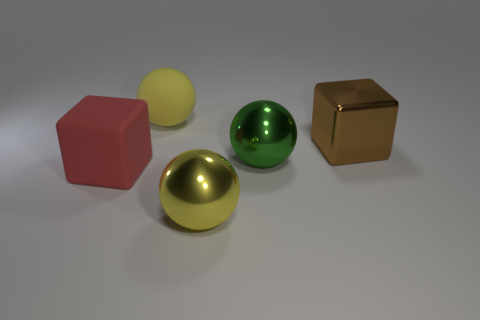Add 5 red cubes. How many objects exist? 10 Subtract all blocks. How many objects are left? 3 Add 5 large green metal spheres. How many large green metal spheres exist? 6 Subtract 0 purple cubes. How many objects are left? 5 Subtract all green spheres. Subtract all small matte balls. How many objects are left? 4 Add 3 large rubber things. How many large rubber things are left? 5 